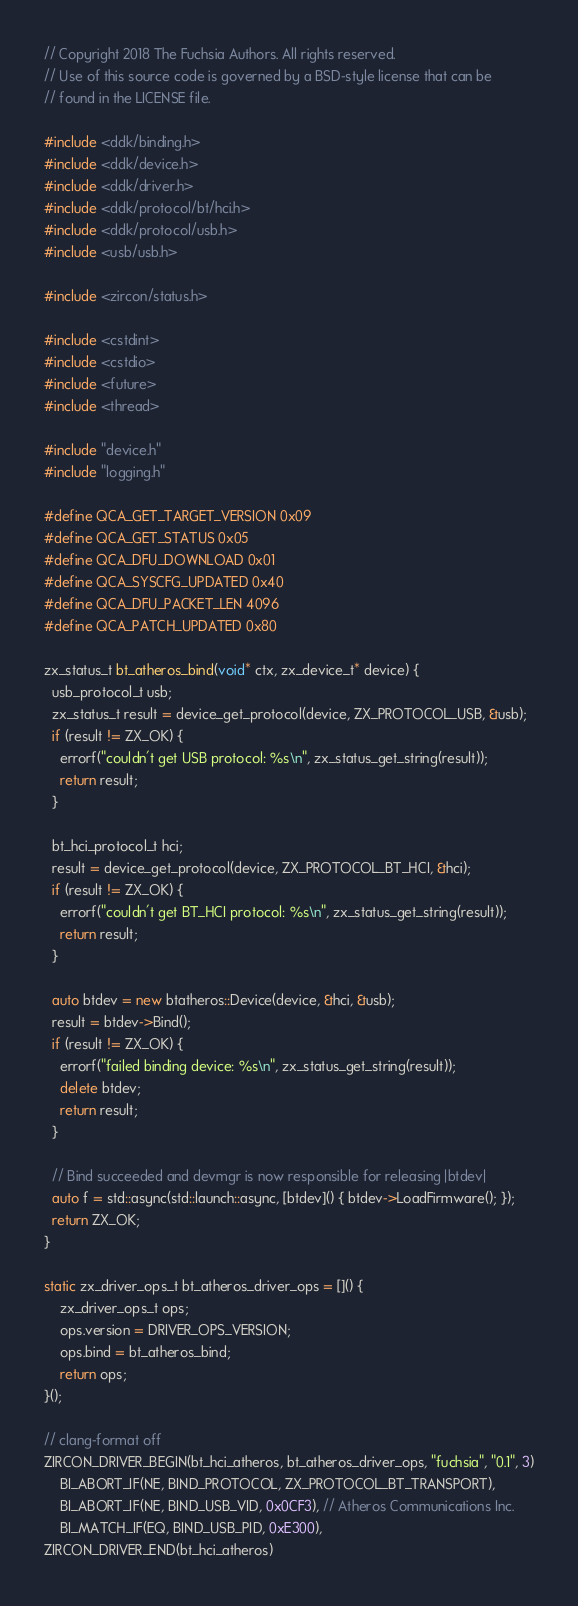Convert code to text. <code><loc_0><loc_0><loc_500><loc_500><_C++_>// Copyright 2018 The Fuchsia Authors. All rights reserved.
// Use of this source code is governed by a BSD-style license that can be
// found in the LICENSE file.

#include <ddk/binding.h>
#include <ddk/device.h>
#include <ddk/driver.h>
#include <ddk/protocol/bt/hci.h>
#include <ddk/protocol/usb.h>
#include <usb/usb.h>

#include <zircon/status.h>

#include <cstdint>
#include <cstdio>
#include <future>
#include <thread>

#include "device.h"
#include "logging.h"

#define QCA_GET_TARGET_VERSION 0x09
#define QCA_GET_STATUS 0x05
#define QCA_DFU_DOWNLOAD 0x01
#define QCA_SYSCFG_UPDATED 0x40
#define QCA_DFU_PACKET_LEN 4096
#define QCA_PATCH_UPDATED 0x80

zx_status_t bt_atheros_bind(void* ctx, zx_device_t* device) {
  usb_protocol_t usb;
  zx_status_t result = device_get_protocol(device, ZX_PROTOCOL_USB, &usb);
  if (result != ZX_OK) {
    errorf("couldn't get USB protocol: %s\n", zx_status_get_string(result));
    return result;
  }

  bt_hci_protocol_t hci;
  result = device_get_protocol(device, ZX_PROTOCOL_BT_HCI, &hci);
  if (result != ZX_OK) {
    errorf("couldn't get BT_HCI protocol: %s\n", zx_status_get_string(result));
    return result;
  }

  auto btdev = new btatheros::Device(device, &hci, &usb);
  result = btdev->Bind();
  if (result != ZX_OK) {
    errorf("failed binding device: %s\n", zx_status_get_string(result));
    delete btdev;
    return result;
  }

  // Bind succeeded and devmgr is now responsible for releasing |btdev|
  auto f = std::async(std::launch::async, [btdev]() { btdev->LoadFirmware(); });
  return ZX_OK;
}

static zx_driver_ops_t bt_atheros_driver_ops = []() {
    zx_driver_ops_t ops;
    ops.version = DRIVER_OPS_VERSION;
    ops.bind = bt_atheros_bind;
    return ops;
}();

// clang-format off
ZIRCON_DRIVER_BEGIN(bt_hci_atheros, bt_atheros_driver_ops, "fuchsia", "0.1", 3)
    BI_ABORT_IF(NE, BIND_PROTOCOL, ZX_PROTOCOL_BT_TRANSPORT),
    BI_ABORT_IF(NE, BIND_USB_VID, 0x0CF3), // Atheros Communications Inc.
    BI_MATCH_IF(EQ, BIND_USB_PID, 0xE300),
ZIRCON_DRIVER_END(bt_hci_atheros)
</code> 